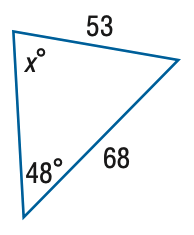Question: Find x. Round the angle measure to the nearest degree.
Choices:
A. 68
B. 72
C. 76
D. 80
Answer with the letter. Answer: B 